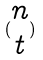<formula> <loc_0><loc_0><loc_500><loc_500>( \begin{matrix} n \\ t \end{matrix} )</formula> 